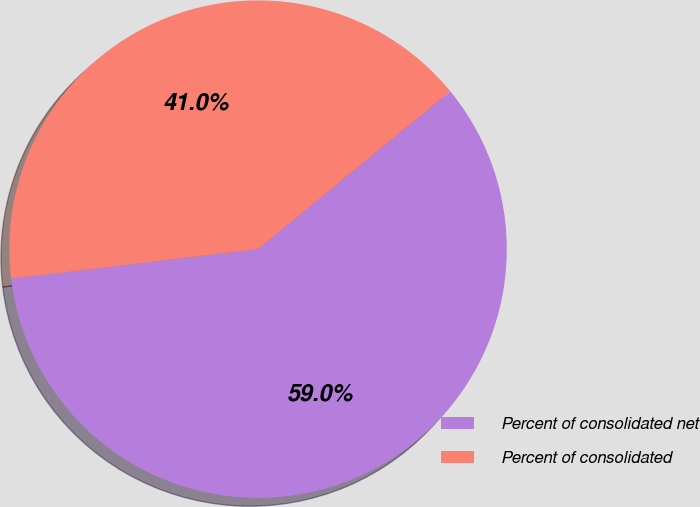Convert chart to OTSL. <chart><loc_0><loc_0><loc_500><loc_500><pie_chart><fcel>Percent of consolidated net<fcel>Percent of consolidated<nl><fcel>59.04%<fcel>40.96%<nl></chart> 